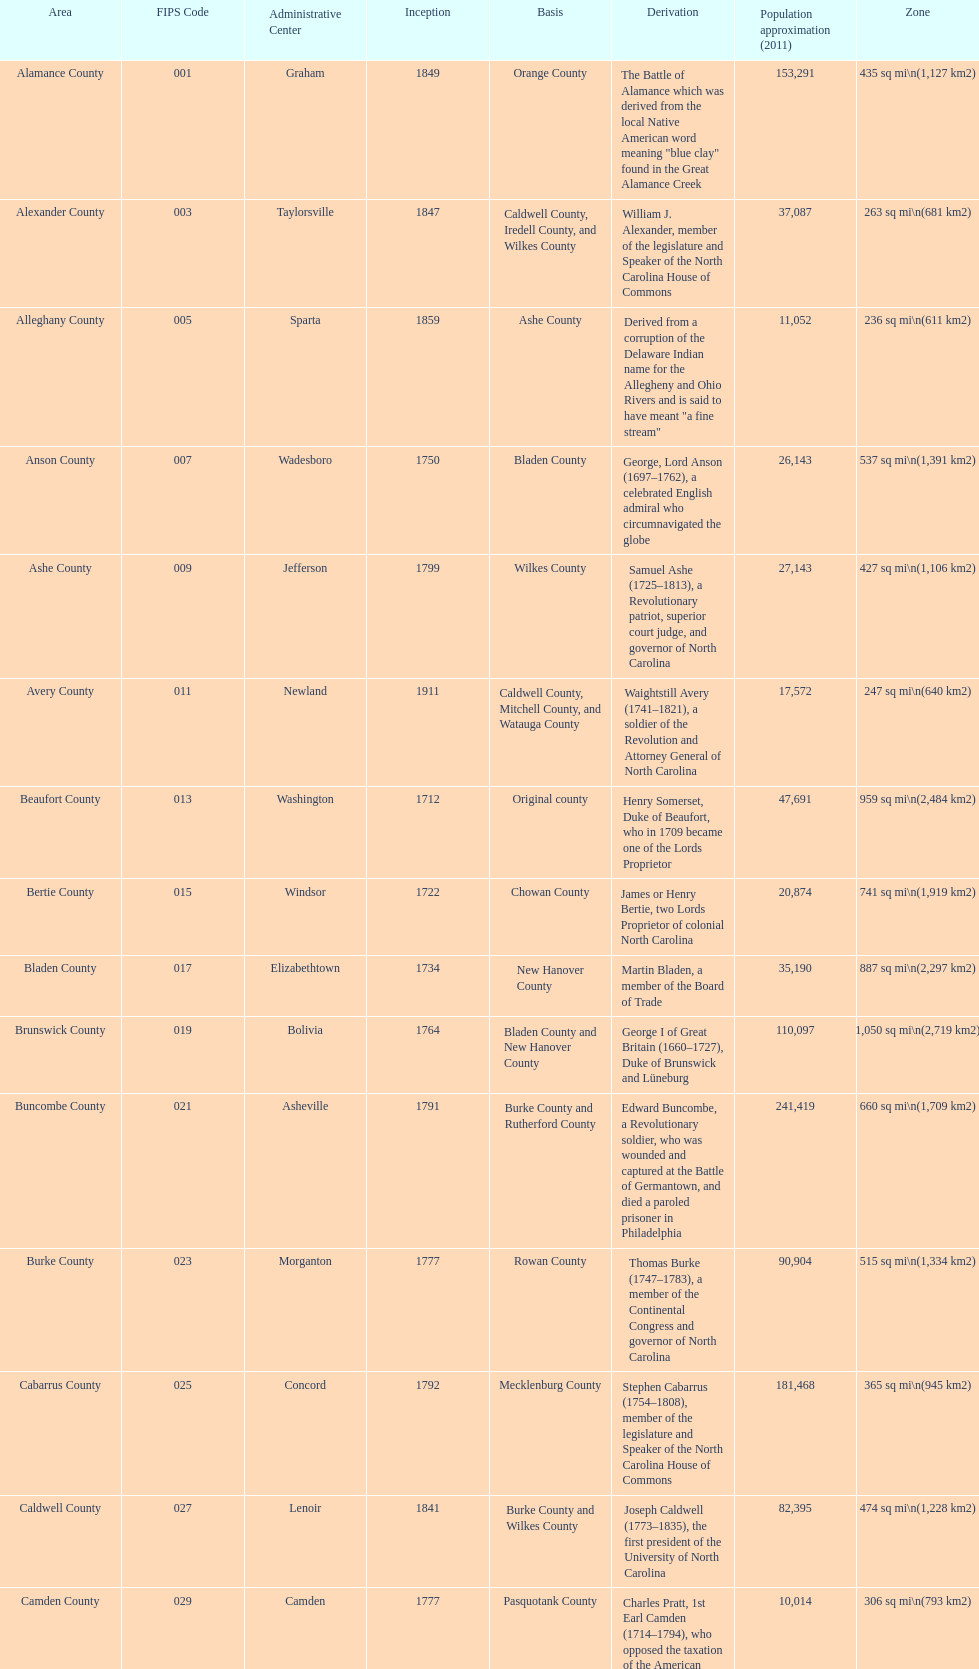What is the total number of counties listed? 100. 